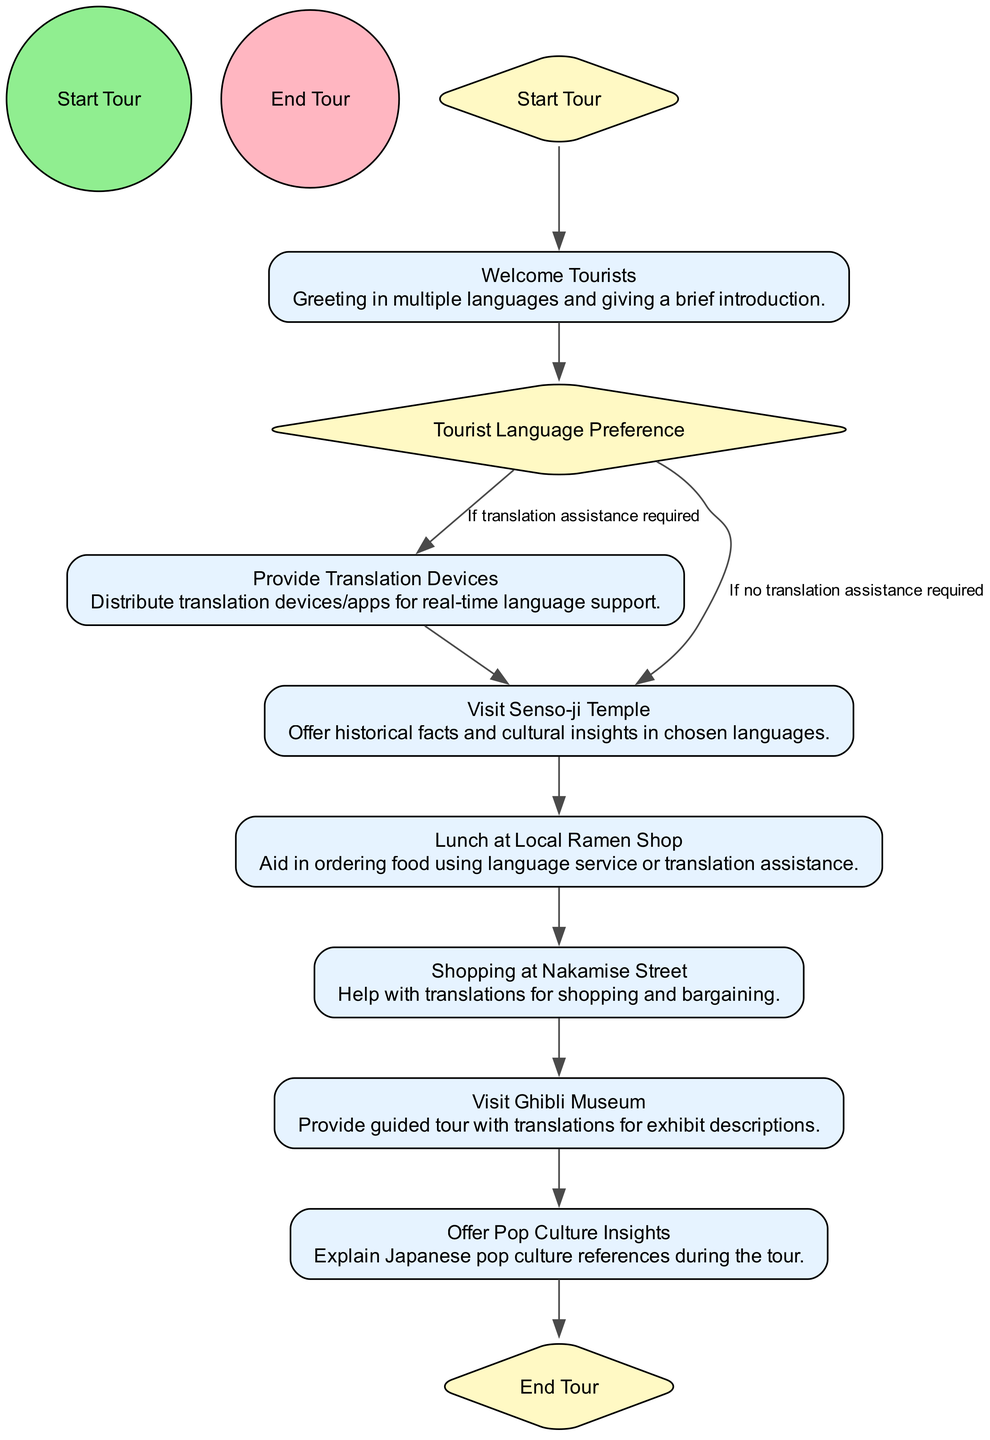What is the starting point of the activity diagram? The starting point of the activity diagram is represented by the node labeled "Start Tour." This is the first activity in the flow, indicating where the sequence begins.
Answer: Start Tour How many activities are presented in the diagram? The diagram contains a total of seven activities. These include different tourist activities such as "Welcome Tourists" and "Visit Ghibli Museum."
Answer: Seven What is the decision point in the diagram? The decision point in the diagram is labeled "Tourist Language Preference." This node determines the flow based on the tourists' language needs.
Answer: Tourist Language Preference What happens if tourists require translation assistance? If tourists require translation assistance, the flow leads to the node "Provide Translation Devices," which ensures they have the necessary tools for communication.
Answer: Provide Translation Devices How many total edges are there in the flows of the diagram? There are ten total edges in the diagram, which represent the connections and transitions between various nodes, guiding the flow of activities.
Answer: Ten What activity comes after "Lunch at Local Ramen Shop"? After "Lunch at Local Ramen Shop," the next activity in the flow is "Shopping at Nakamise Street." This maintains the continuity of the tour experiences.
Answer: Shopping at Nakamise Street What is the last activity before ending the tour? The last activity before the tour ends is labeled "Offer Pop Culture Insights." This activity provides valuable cultural context before concluding the tour.
Answer: Offer Pop Culture Insights What activity follows "Visit Senso-ji Temple" if no translation assistance is needed? If no translation assistance is needed, the next activity that follows "Visit Senso-ji Temple" is "Lunch at Local Ramen Shop." This indicates a seamless transition in the itinerary.
Answer: Lunch at Local Ramen Shop 